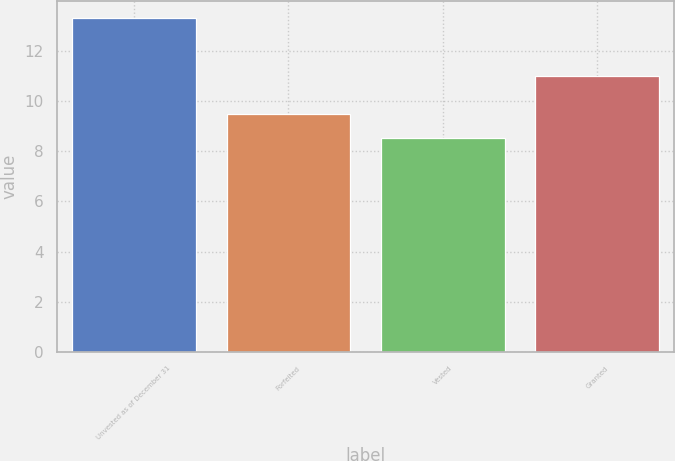Convert chart. <chart><loc_0><loc_0><loc_500><loc_500><bar_chart><fcel>Unvested as of December 31<fcel>Forfeited<fcel>Vested<fcel>Granted<nl><fcel>13.31<fcel>9.48<fcel>8.51<fcel>10.99<nl></chart> 